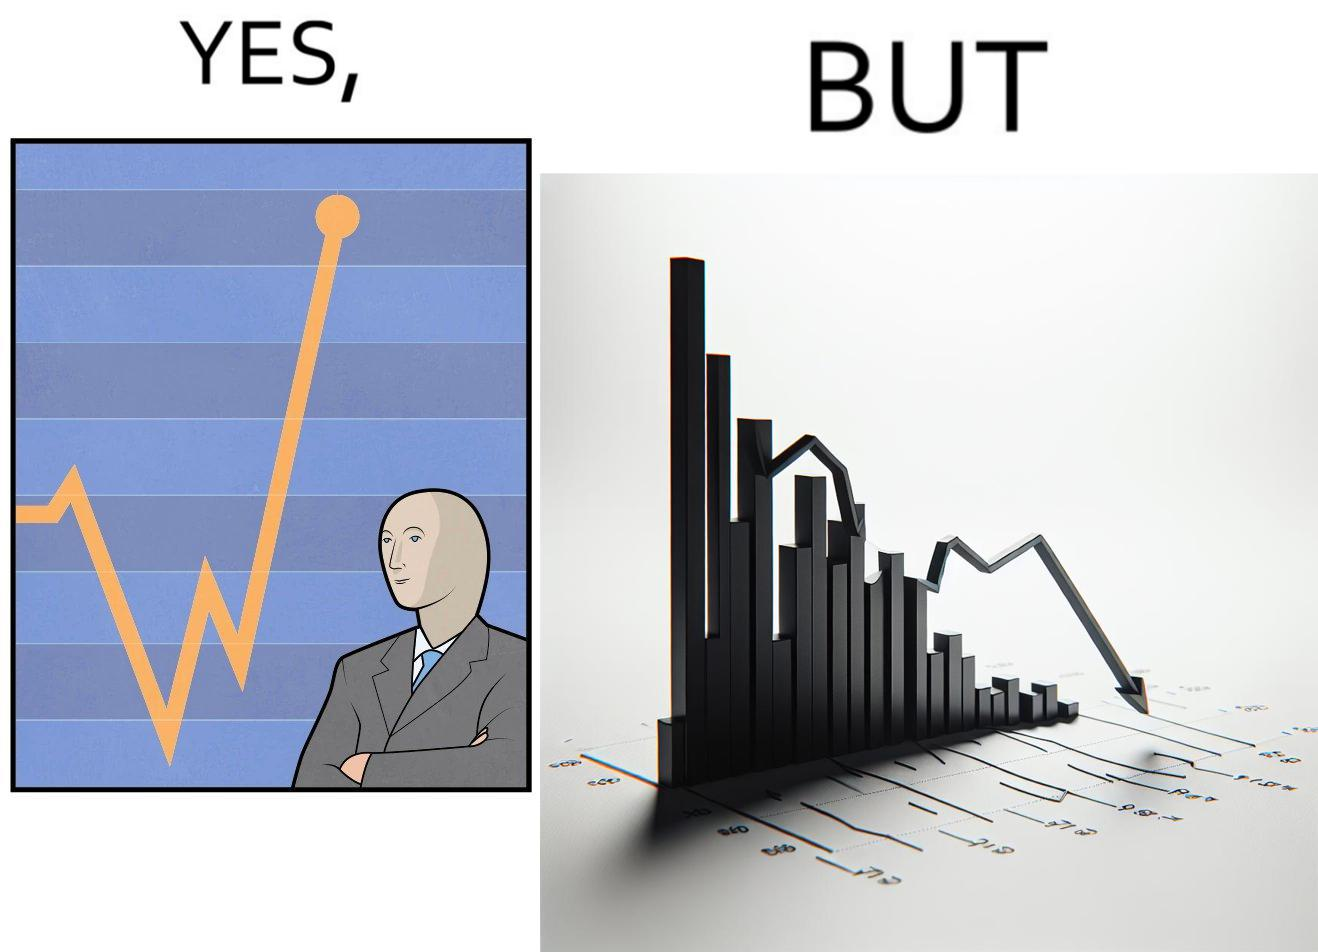Would you classify this image as satirical? Yes, this image is satirical. 